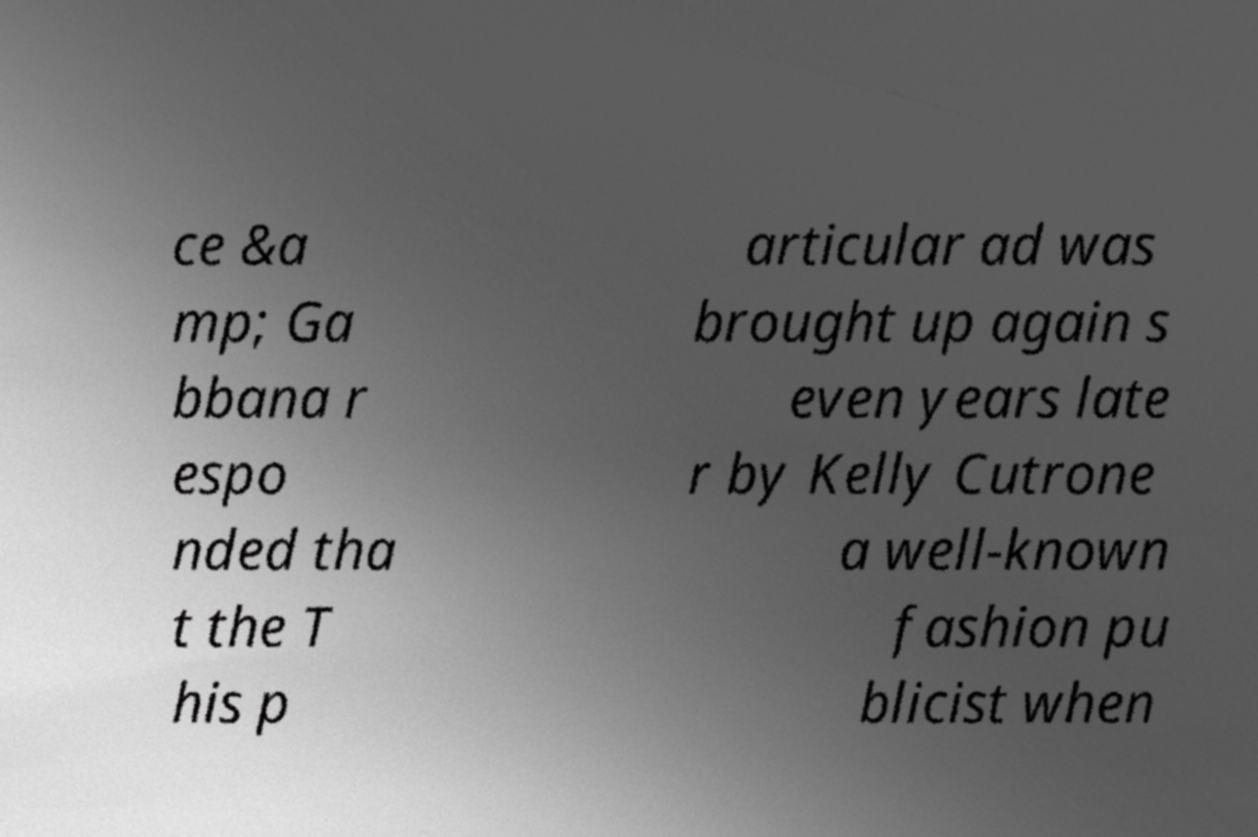Can you read and provide the text displayed in the image?This photo seems to have some interesting text. Can you extract and type it out for me? ce &a mp; Ga bbana r espo nded tha t the T his p articular ad was brought up again s even years late r by Kelly Cutrone a well-known fashion pu blicist when 